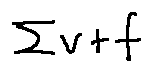<formula> <loc_0><loc_0><loc_500><loc_500>\sum v + f</formula> 